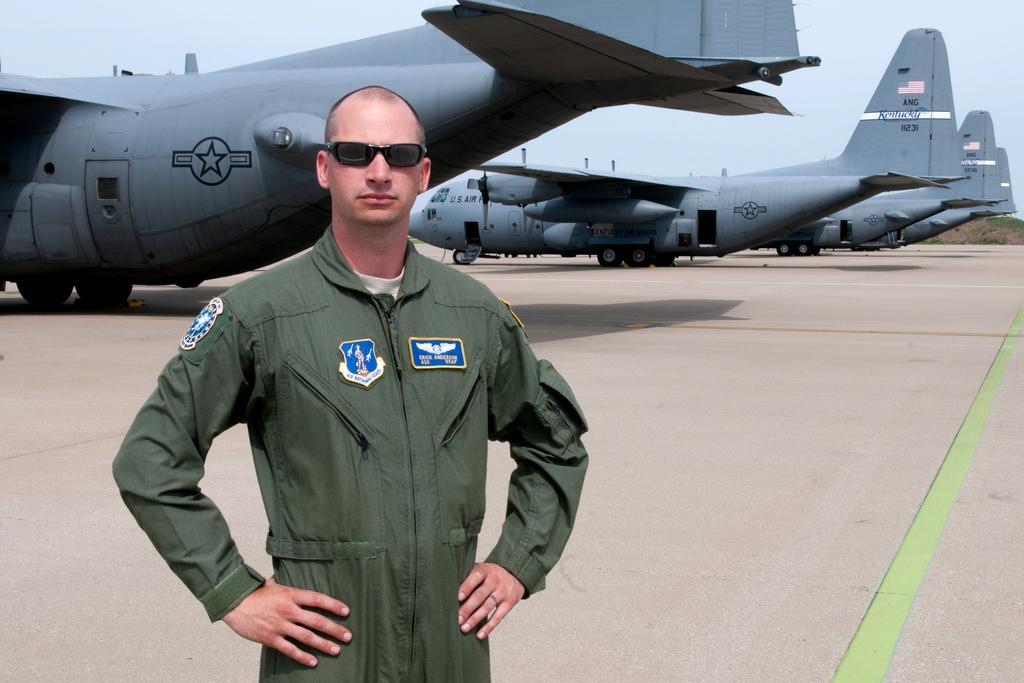Could you give a brief overview of what you see in this image? In this picture we can see a man wore goggles and standing and at the back of them we can see airplanes on the ground and in the background we can see the grass, sky. 